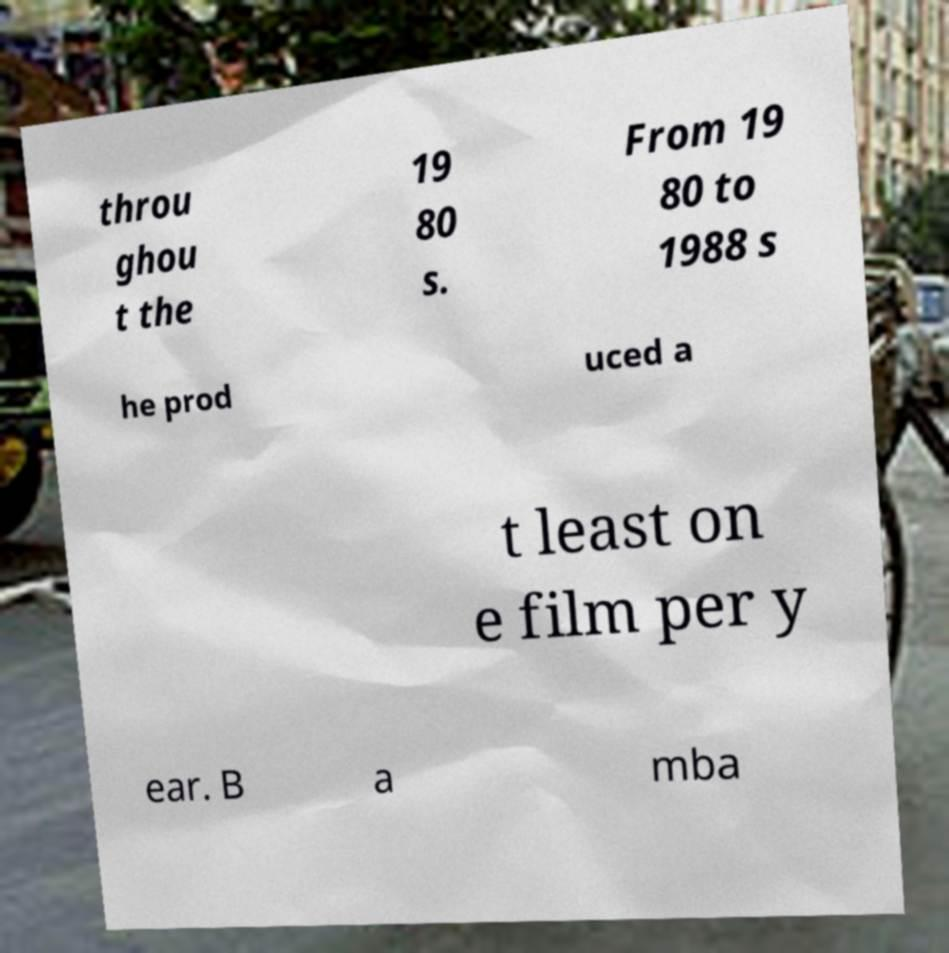Please identify and transcribe the text found in this image. throu ghou t the 19 80 s. From 19 80 to 1988 s he prod uced a t least on e film per y ear. B a mba 